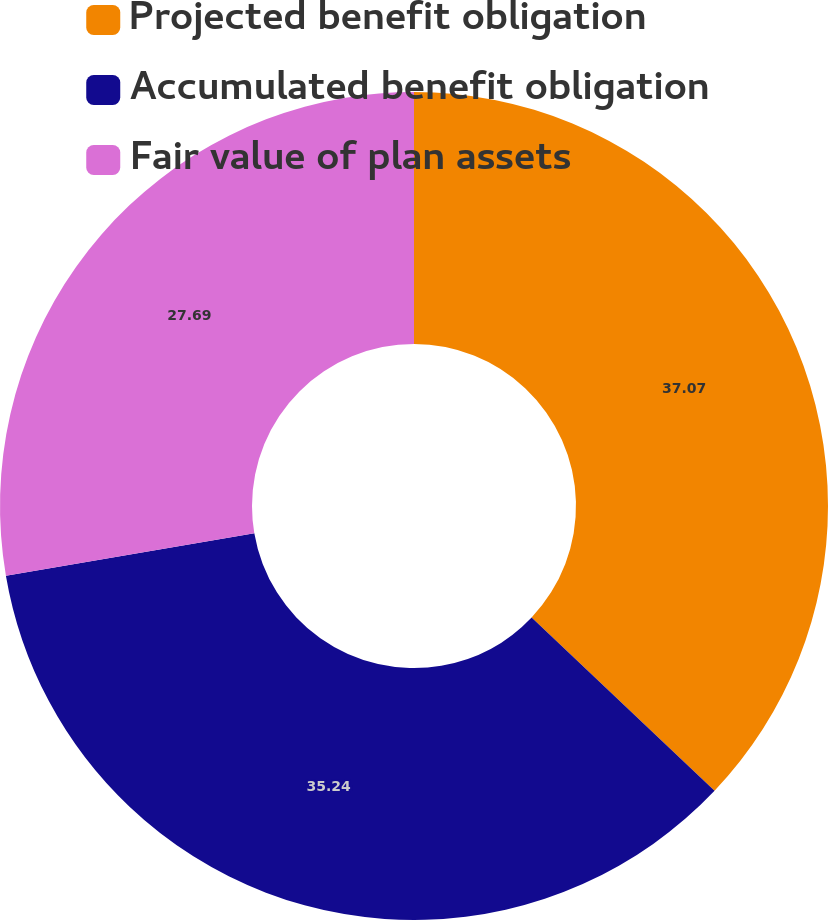Convert chart to OTSL. <chart><loc_0><loc_0><loc_500><loc_500><pie_chart><fcel>Projected benefit obligation<fcel>Accumulated benefit obligation<fcel>Fair value of plan assets<nl><fcel>37.07%<fcel>35.24%<fcel>27.69%<nl></chart> 